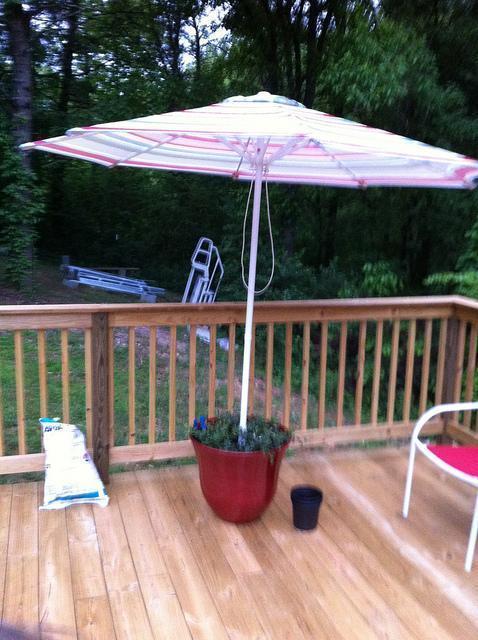What is inside the flower pot?
Choose the correct response, then elucidate: 'Answer: answer
Rationale: rationale.'
Options: Umbrella, cat, baby, single rose. Answer: umbrella.
Rationale: The flower pot on the deck has an umbrella pole inside of it. 